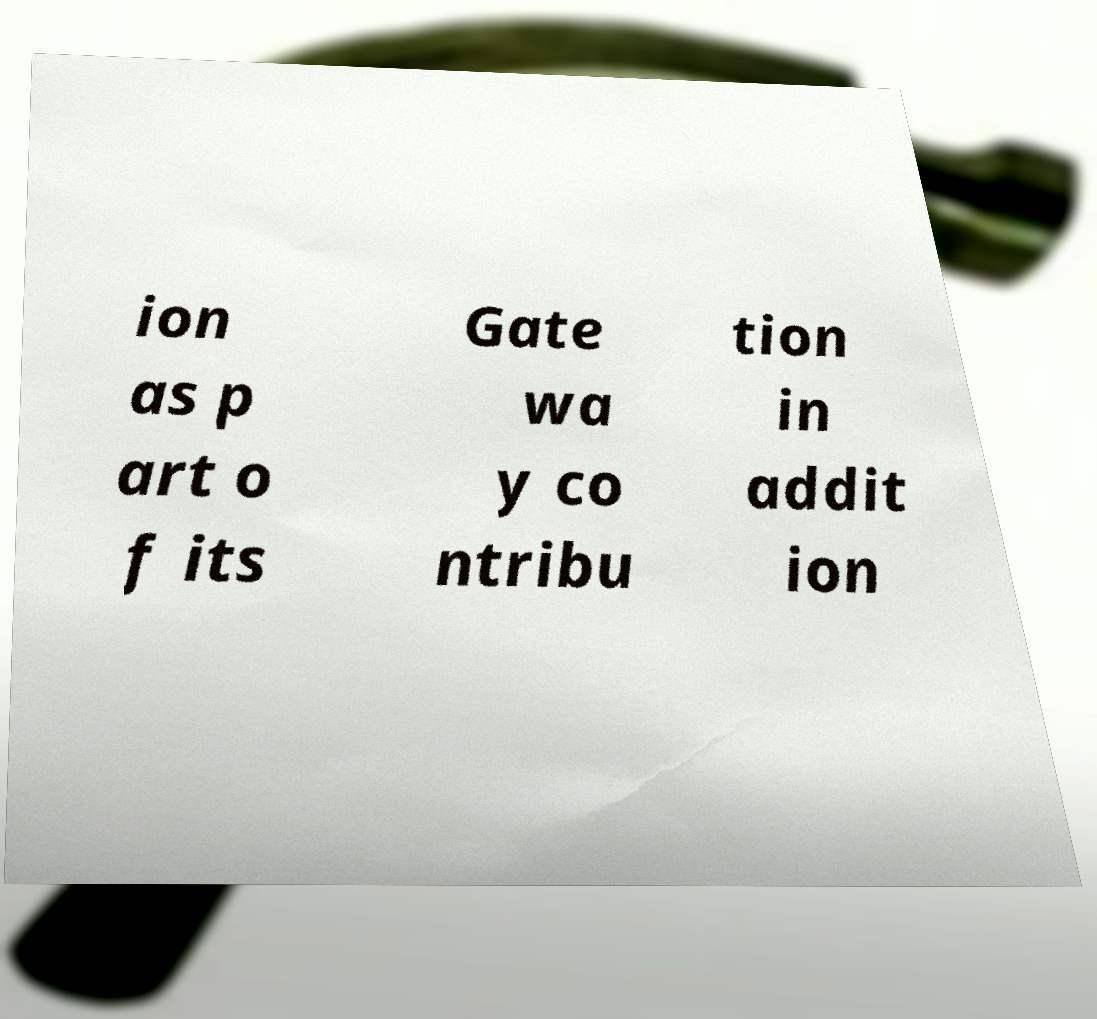Can you accurately transcribe the text from the provided image for me? ion as p art o f its Gate wa y co ntribu tion in addit ion 